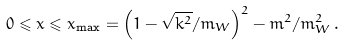Convert formula to latex. <formula><loc_0><loc_0><loc_500><loc_500>0 \leqslant x \leqslant x _ { \max } = \left ( 1 - \sqrt { k ^ { 2 } } / m _ { W } \right ) ^ { 2 } - m ^ { 2 } / m _ { W } ^ { 2 } \, .</formula> 